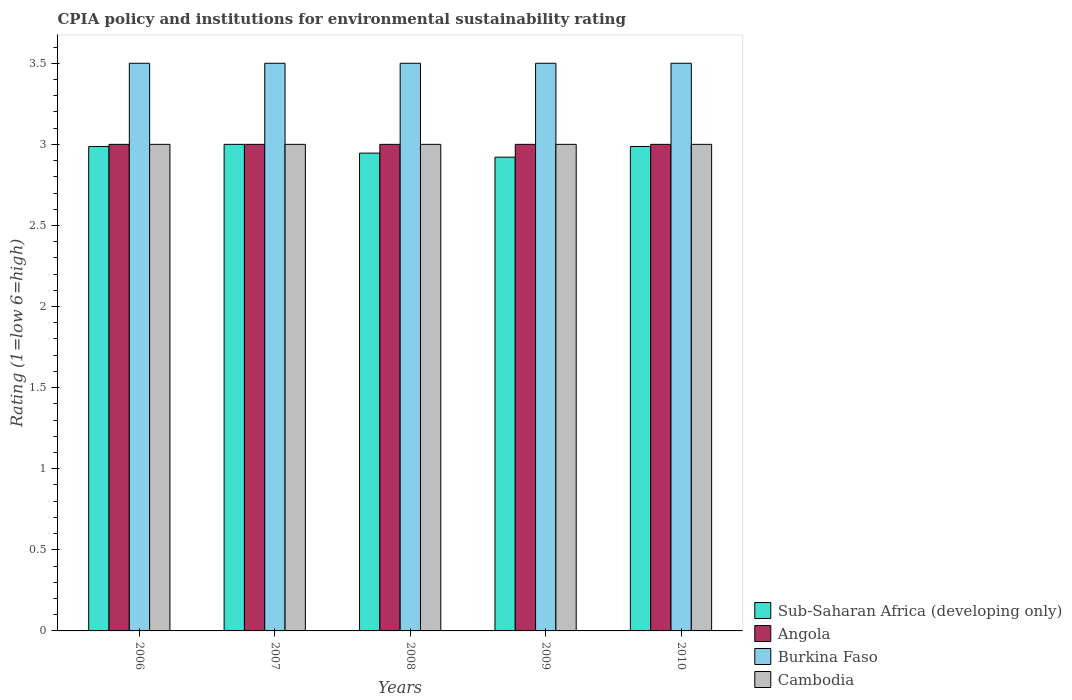How many different coloured bars are there?
Your response must be concise. 4. How many groups of bars are there?
Offer a very short reply. 5. Are the number of bars per tick equal to the number of legend labels?
Provide a succinct answer. Yes. How many bars are there on the 2nd tick from the left?
Offer a terse response. 4. In how many cases, is the number of bars for a given year not equal to the number of legend labels?
Offer a very short reply. 0. Across all years, what is the minimum CPIA rating in Sub-Saharan Africa (developing only)?
Make the answer very short. 2.92. What is the total CPIA rating in Angola in the graph?
Your answer should be compact. 15. Is the difference between the CPIA rating in Cambodia in 2006 and 2009 greater than the difference between the CPIA rating in Angola in 2006 and 2009?
Your response must be concise. No. What is the difference between the highest and the second highest CPIA rating in Cambodia?
Give a very brief answer. 0. Is it the case that in every year, the sum of the CPIA rating in Cambodia and CPIA rating in Sub-Saharan Africa (developing only) is greater than the sum of CPIA rating in Angola and CPIA rating in Burkina Faso?
Provide a succinct answer. No. What does the 4th bar from the left in 2006 represents?
Your response must be concise. Cambodia. What does the 4th bar from the right in 2008 represents?
Provide a short and direct response. Sub-Saharan Africa (developing only). What is the difference between two consecutive major ticks on the Y-axis?
Offer a very short reply. 0.5. Are the values on the major ticks of Y-axis written in scientific E-notation?
Make the answer very short. No. Does the graph contain any zero values?
Your response must be concise. No. Does the graph contain grids?
Offer a very short reply. No. How many legend labels are there?
Provide a short and direct response. 4. What is the title of the graph?
Give a very brief answer. CPIA policy and institutions for environmental sustainability rating. Does "Cuba" appear as one of the legend labels in the graph?
Your answer should be very brief. No. What is the label or title of the X-axis?
Make the answer very short. Years. What is the label or title of the Y-axis?
Provide a succinct answer. Rating (1=low 6=high). What is the Rating (1=low 6=high) in Sub-Saharan Africa (developing only) in 2006?
Offer a very short reply. 2.99. What is the Rating (1=low 6=high) of Angola in 2006?
Give a very brief answer. 3. What is the Rating (1=low 6=high) of Cambodia in 2007?
Give a very brief answer. 3. What is the Rating (1=low 6=high) in Sub-Saharan Africa (developing only) in 2008?
Ensure brevity in your answer.  2.95. What is the Rating (1=low 6=high) of Angola in 2008?
Your response must be concise. 3. What is the Rating (1=low 6=high) in Burkina Faso in 2008?
Your answer should be very brief. 3.5. What is the Rating (1=low 6=high) in Cambodia in 2008?
Provide a succinct answer. 3. What is the Rating (1=low 6=high) in Sub-Saharan Africa (developing only) in 2009?
Provide a short and direct response. 2.92. What is the Rating (1=low 6=high) in Angola in 2009?
Offer a terse response. 3. What is the Rating (1=low 6=high) of Burkina Faso in 2009?
Your answer should be compact. 3.5. What is the Rating (1=low 6=high) in Sub-Saharan Africa (developing only) in 2010?
Your answer should be compact. 2.99. What is the Rating (1=low 6=high) of Angola in 2010?
Ensure brevity in your answer.  3. What is the Rating (1=low 6=high) in Burkina Faso in 2010?
Offer a terse response. 3.5. Across all years, what is the maximum Rating (1=low 6=high) in Angola?
Your answer should be very brief. 3. Across all years, what is the maximum Rating (1=low 6=high) in Burkina Faso?
Ensure brevity in your answer.  3.5. Across all years, what is the maximum Rating (1=low 6=high) of Cambodia?
Keep it short and to the point. 3. Across all years, what is the minimum Rating (1=low 6=high) of Sub-Saharan Africa (developing only)?
Keep it short and to the point. 2.92. Across all years, what is the minimum Rating (1=low 6=high) of Burkina Faso?
Keep it short and to the point. 3.5. What is the total Rating (1=low 6=high) in Sub-Saharan Africa (developing only) in the graph?
Give a very brief answer. 14.84. What is the total Rating (1=low 6=high) in Angola in the graph?
Your response must be concise. 15. What is the difference between the Rating (1=low 6=high) of Sub-Saharan Africa (developing only) in 2006 and that in 2007?
Offer a very short reply. -0.01. What is the difference between the Rating (1=low 6=high) of Angola in 2006 and that in 2007?
Your response must be concise. 0. What is the difference between the Rating (1=low 6=high) in Burkina Faso in 2006 and that in 2007?
Offer a very short reply. 0. What is the difference between the Rating (1=low 6=high) in Sub-Saharan Africa (developing only) in 2006 and that in 2008?
Your response must be concise. 0.04. What is the difference between the Rating (1=low 6=high) of Angola in 2006 and that in 2008?
Provide a succinct answer. 0. What is the difference between the Rating (1=low 6=high) in Burkina Faso in 2006 and that in 2008?
Your answer should be very brief. 0. What is the difference between the Rating (1=low 6=high) in Cambodia in 2006 and that in 2008?
Offer a very short reply. 0. What is the difference between the Rating (1=low 6=high) in Sub-Saharan Africa (developing only) in 2006 and that in 2009?
Offer a terse response. 0.07. What is the difference between the Rating (1=low 6=high) in Burkina Faso in 2006 and that in 2009?
Provide a short and direct response. 0. What is the difference between the Rating (1=low 6=high) in Sub-Saharan Africa (developing only) in 2006 and that in 2010?
Provide a short and direct response. -0. What is the difference between the Rating (1=low 6=high) in Burkina Faso in 2006 and that in 2010?
Ensure brevity in your answer.  0. What is the difference between the Rating (1=low 6=high) of Sub-Saharan Africa (developing only) in 2007 and that in 2008?
Provide a succinct answer. 0.05. What is the difference between the Rating (1=low 6=high) in Burkina Faso in 2007 and that in 2008?
Offer a terse response. 0. What is the difference between the Rating (1=low 6=high) of Sub-Saharan Africa (developing only) in 2007 and that in 2009?
Your answer should be compact. 0.08. What is the difference between the Rating (1=low 6=high) in Burkina Faso in 2007 and that in 2009?
Your answer should be very brief. 0. What is the difference between the Rating (1=low 6=high) of Cambodia in 2007 and that in 2009?
Keep it short and to the point. 0. What is the difference between the Rating (1=low 6=high) of Sub-Saharan Africa (developing only) in 2007 and that in 2010?
Keep it short and to the point. 0.01. What is the difference between the Rating (1=low 6=high) of Cambodia in 2007 and that in 2010?
Your response must be concise. 0. What is the difference between the Rating (1=low 6=high) of Sub-Saharan Africa (developing only) in 2008 and that in 2009?
Make the answer very short. 0.02. What is the difference between the Rating (1=low 6=high) in Burkina Faso in 2008 and that in 2009?
Provide a succinct answer. 0. What is the difference between the Rating (1=low 6=high) of Cambodia in 2008 and that in 2009?
Offer a very short reply. 0. What is the difference between the Rating (1=low 6=high) in Sub-Saharan Africa (developing only) in 2008 and that in 2010?
Offer a very short reply. -0.04. What is the difference between the Rating (1=low 6=high) of Angola in 2008 and that in 2010?
Provide a succinct answer. 0. What is the difference between the Rating (1=low 6=high) of Burkina Faso in 2008 and that in 2010?
Ensure brevity in your answer.  0. What is the difference between the Rating (1=low 6=high) in Cambodia in 2008 and that in 2010?
Make the answer very short. 0. What is the difference between the Rating (1=low 6=high) in Sub-Saharan Africa (developing only) in 2009 and that in 2010?
Your answer should be very brief. -0.07. What is the difference between the Rating (1=low 6=high) of Angola in 2009 and that in 2010?
Provide a succinct answer. 0. What is the difference between the Rating (1=low 6=high) in Burkina Faso in 2009 and that in 2010?
Your answer should be compact. 0. What is the difference between the Rating (1=low 6=high) in Cambodia in 2009 and that in 2010?
Provide a succinct answer. 0. What is the difference between the Rating (1=low 6=high) of Sub-Saharan Africa (developing only) in 2006 and the Rating (1=low 6=high) of Angola in 2007?
Keep it short and to the point. -0.01. What is the difference between the Rating (1=low 6=high) in Sub-Saharan Africa (developing only) in 2006 and the Rating (1=low 6=high) in Burkina Faso in 2007?
Offer a very short reply. -0.51. What is the difference between the Rating (1=low 6=high) in Sub-Saharan Africa (developing only) in 2006 and the Rating (1=low 6=high) in Cambodia in 2007?
Offer a very short reply. -0.01. What is the difference between the Rating (1=low 6=high) in Angola in 2006 and the Rating (1=low 6=high) in Cambodia in 2007?
Offer a very short reply. 0. What is the difference between the Rating (1=low 6=high) of Sub-Saharan Africa (developing only) in 2006 and the Rating (1=low 6=high) of Angola in 2008?
Give a very brief answer. -0.01. What is the difference between the Rating (1=low 6=high) of Sub-Saharan Africa (developing only) in 2006 and the Rating (1=low 6=high) of Burkina Faso in 2008?
Give a very brief answer. -0.51. What is the difference between the Rating (1=low 6=high) of Sub-Saharan Africa (developing only) in 2006 and the Rating (1=low 6=high) of Cambodia in 2008?
Ensure brevity in your answer.  -0.01. What is the difference between the Rating (1=low 6=high) of Angola in 2006 and the Rating (1=low 6=high) of Burkina Faso in 2008?
Ensure brevity in your answer.  -0.5. What is the difference between the Rating (1=low 6=high) of Burkina Faso in 2006 and the Rating (1=low 6=high) of Cambodia in 2008?
Provide a succinct answer. 0.5. What is the difference between the Rating (1=low 6=high) in Sub-Saharan Africa (developing only) in 2006 and the Rating (1=low 6=high) in Angola in 2009?
Provide a succinct answer. -0.01. What is the difference between the Rating (1=low 6=high) of Sub-Saharan Africa (developing only) in 2006 and the Rating (1=low 6=high) of Burkina Faso in 2009?
Your answer should be compact. -0.51. What is the difference between the Rating (1=low 6=high) of Sub-Saharan Africa (developing only) in 2006 and the Rating (1=low 6=high) of Cambodia in 2009?
Your answer should be compact. -0.01. What is the difference between the Rating (1=low 6=high) of Angola in 2006 and the Rating (1=low 6=high) of Burkina Faso in 2009?
Provide a short and direct response. -0.5. What is the difference between the Rating (1=low 6=high) of Burkina Faso in 2006 and the Rating (1=low 6=high) of Cambodia in 2009?
Provide a short and direct response. 0.5. What is the difference between the Rating (1=low 6=high) of Sub-Saharan Africa (developing only) in 2006 and the Rating (1=low 6=high) of Angola in 2010?
Provide a succinct answer. -0.01. What is the difference between the Rating (1=low 6=high) in Sub-Saharan Africa (developing only) in 2006 and the Rating (1=low 6=high) in Burkina Faso in 2010?
Offer a very short reply. -0.51. What is the difference between the Rating (1=low 6=high) of Sub-Saharan Africa (developing only) in 2006 and the Rating (1=low 6=high) of Cambodia in 2010?
Provide a succinct answer. -0.01. What is the difference between the Rating (1=low 6=high) of Angola in 2006 and the Rating (1=low 6=high) of Burkina Faso in 2010?
Your answer should be very brief. -0.5. What is the difference between the Rating (1=low 6=high) in Angola in 2006 and the Rating (1=low 6=high) in Cambodia in 2010?
Your answer should be compact. 0. What is the difference between the Rating (1=low 6=high) in Burkina Faso in 2006 and the Rating (1=low 6=high) in Cambodia in 2010?
Make the answer very short. 0.5. What is the difference between the Rating (1=low 6=high) in Angola in 2007 and the Rating (1=low 6=high) in Cambodia in 2008?
Ensure brevity in your answer.  0. What is the difference between the Rating (1=low 6=high) in Angola in 2007 and the Rating (1=low 6=high) in Burkina Faso in 2009?
Offer a very short reply. -0.5. What is the difference between the Rating (1=low 6=high) in Burkina Faso in 2007 and the Rating (1=low 6=high) in Cambodia in 2009?
Ensure brevity in your answer.  0.5. What is the difference between the Rating (1=low 6=high) of Sub-Saharan Africa (developing only) in 2008 and the Rating (1=low 6=high) of Angola in 2009?
Your answer should be very brief. -0.05. What is the difference between the Rating (1=low 6=high) of Sub-Saharan Africa (developing only) in 2008 and the Rating (1=low 6=high) of Burkina Faso in 2009?
Your answer should be compact. -0.55. What is the difference between the Rating (1=low 6=high) of Sub-Saharan Africa (developing only) in 2008 and the Rating (1=low 6=high) of Cambodia in 2009?
Provide a short and direct response. -0.05. What is the difference between the Rating (1=low 6=high) in Angola in 2008 and the Rating (1=low 6=high) in Burkina Faso in 2009?
Offer a terse response. -0.5. What is the difference between the Rating (1=low 6=high) of Angola in 2008 and the Rating (1=low 6=high) of Cambodia in 2009?
Your answer should be very brief. 0. What is the difference between the Rating (1=low 6=high) of Sub-Saharan Africa (developing only) in 2008 and the Rating (1=low 6=high) of Angola in 2010?
Offer a very short reply. -0.05. What is the difference between the Rating (1=low 6=high) of Sub-Saharan Africa (developing only) in 2008 and the Rating (1=low 6=high) of Burkina Faso in 2010?
Give a very brief answer. -0.55. What is the difference between the Rating (1=low 6=high) of Sub-Saharan Africa (developing only) in 2008 and the Rating (1=low 6=high) of Cambodia in 2010?
Provide a short and direct response. -0.05. What is the difference between the Rating (1=low 6=high) in Angola in 2008 and the Rating (1=low 6=high) in Burkina Faso in 2010?
Your answer should be compact. -0.5. What is the difference between the Rating (1=low 6=high) in Sub-Saharan Africa (developing only) in 2009 and the Rating (1=low 6=high) in Angola in 2010?
Provide a short and direct response. -0.08. What is the difference between the Rating (1=low 6=high) in Sub-Saharan Africa (developing only) in 2009 and the Rating (1=low 6=high) in Burkina Faso in 2010?
Offer a very short reply. -0.58. What is the difference between the Rating (1=low 6=high) of Sub-Saharan Africa (developing only) in 2009 and the Rating (1=low 6=high) of Cambodia in 2010?
Your answer should be compact. -0.08. What is the difference between the Rating (1=low 6=high) in Angola in 2009 and the Rating (1=low 6=high) in Cambodia in 2010?
Provide a short and direct response. 0. What is the average Rating (1=low 6=high) in Sub-Saharan Africa (developing only) per year?
Provide a short and direct response. 2.97. What is the average Rating (1=low 6=high) of Angola per year?
Your response must be concise. 3. What is the average Rating (1=low 6=high) of Cambodia per year?
Make the answer very short. 3. In the year 2006, what is the difference between the Rating (1=low 6=high) in Sub-Saharan Africa (developing only) and Rating (1=low 6=high) in Angola?
Your answer should be compact. -0.01. In the year 2006, what is the difference between the Rating (1=low 6=high) of Sub-Saharan Africa (developing only) and Rating (1=low 6=high) of Burkina Faso?
Provide a short and direct response. -0.51. In the year 2006, what is the difference between the Rating (1=low 6=high) of Sub-Saharan Africa (developing only) and Rating (1=low 6=high) of Cambodia?
Provide a short and direct response. -0.01. In the year 2006, what is the difference between the Rating (1=low 6=high) in Angola and Rating (1=low 6=high) in Burkina Faso?
Make the answer very short. -0.5. In the year 2006, what is the difference between the Rating (1=low 6=high) in Angola and Rating (1=low 6=high) in Cambodia?
Offer a very short reply. 0. In the year 2007, what is the difference between the Rating (1=low 6=high) in Angola and Rating (1=low 6=high) in Burkina Faso?
Make the answer very short. -0.5. In the year 2007, what is the difference between the Rating (1=low 6=high) of Angola and Rating (1=low 6=high) of Cambodia?
Keep it short and to the point. 0. In the year 2008, what is the difference between the Rating (1=low 6=high) in Sub-Saharan Africa (developing only) and Rating (1=low 6=high) in Angola?
Your answer should be very brief. -0.05. In the year 2008, what is the difference between the Rating (1=low 6=high) of Sub-Saharan Africa (developing only) and Rating (1=low 6=high) of Burkina Faso?
Your answer should be very brief. -0.55. In the year 2008, what is the difference between the Rating (1=low 6=high) of Sub-Saharan Africa (developing only) and Rating (1=low 6=high) of Cambodia?
Provide a short and direct response. -0.05. In the year 2008, what is the difference between the Rating (1=low 6=high) in Angola and Rating (1=low 6=high) in Cambodia?
Make the answer very short. 0. In the year 2008, what is the difference between the Rating (1=low 6=high) in Burkina Faso and Rating (1=low 6=high) in Cambodia?
Provide a succinct answer. 0.5. In the year 2009, what is the difference between the Rating (1=low 6=high) of Sub-Saharan Africa (developing only) and Rating (1=low 6=high) of Angola?
Your answer should be very brief. -0.08. In the year 2009, what is the difference between the Rating (1=low 6=high) of Sub-Saharan Africa (developing only) and Rating (1=low 6=high) of Burkina Faso?
Your response must be concise. -0.58. In the year 2009, what is the difference between the Rating (1=low 6=high) of Sub-Saharan Africa (developing only) and Rating (1=low 6=high) of Cambodia?
Offer a terse response. -0.08. In the year 2009, what is the difference between the Rating (1=low 6=high) in Angola and Rating (1=low 6=high) in Burkina Faso?
Offer a terse response. -0.5. In the year 2010, what is the difference between the Rating (1=low 6=high) of Sub-Saharan Africa (developing only) and Rating (1=low 6=high) of Angola?
Your answer should be very brief. -0.01. In the year 2010, what is the difference between the Rating (1=low 6=high) of Sub-Saharan Africa (developing only) and Rating (1=low 6=high) of Burkina Faso?
Offer a terse response. -0.51. In the year 2010, what is the difference between the Rating (1=low 6=high) of Sub-Saharan Africa (developing only) and Rating (1=low 6=high) of Cambodia?
Provide a succinct answer. -0.01. In the year 2010, what is the difference between the Rating (1=low 6=high) in Angola and Rating (1=low 6=high) in Burkina Faso?
Make the answer very short. -0.5. In the year 2010, what is the difference between the Rating (1=low 6=high) of Burkina Faso and Rating (1=low 6=high) of Cambodia?
Make the answer very short. 0.5. What is the ratio of the Rating (1=low 6=high) in Sub-Saharan Africa (developing only) in 2006 to that in 2007?
Make the answer very short. 1. What is the ratio of the Rating (1=low 6=high) of Cambodia in 2006 to that in 2007?
Your answer should be very brief. 1. What is the ratio of the Rating (1=low 6=high) in Sub-Saharan Africa (developing only) in 2006 to that in 2008?
Keep it short and to the point. 1.01. What is the ratio of the Rating (1=low 6=high) in Angola in 2006 to that in 2008?
Provide a succinct answer. 1. What is the ratio of the Rating (1=low 6=high) in Cambodia in 2006 to that in 2008?
Your answer should be very brief. 1. What is the ratio of the Rating (1=low 6=high) of Sub-Saharan Africa (developing only) in 2006 to that in 2009?
Offer a very short reply. 1.02. What is the ratio of the Rating (1=low 6=high) of Sub-Saharan Africa (developing only) in 2006 to that in 2010?
Ensure brevity in your answer.  1. What is the ratio of the Rating (1=low 6=high) of Angola in 2006 to that in 2010?
Your response must be concise. 1. What is the ratio of the Rating (1=low 6=high) in Cambodia in 2006 to that in 2010?
Your response must be concise. 1. What is the ratio of the Rating (1=low 6=high) of Sub-Saharan Africa (developing only) in 2007 to that in 2008?
Offer a very short reply. 1.02. What is the ratio of the Rating (1=low 6=high) of Angola in 2007 to that in 2008?
Give a very brief answer. 1. What is the ratio of the Rating (1=low 6=high) in Burkina Faso in 2007 to that in 2008?
Your response must be concise. 1. What is the ratio of the Rating (1=low 6=high) in Cambodia in 2007 to that in 2008?
Your answer should be very brief. 1. What is the ratio of the Rating (1=low 6=high) of Sub-Saharan Africa (developing only) in 2007 to that in 2009?
Provide a short and direct response. 1.03. What is the ratio of the Rating (1=low 6=high) of Angola in 2007 to that in 2009?
Provide a succinct answer. 1. What is the ratio of the Rating (1=low 6=high) of Burkina Faso in 2007 to that in 2009?
Provide a succinct answer. 1. What is the ratio of the Rating (1=low 6=high) of Cambodia in 2007 to that in 2009?
Offer a terse response. 1. What is the ratio of the Rating (1=low 6=high) of Sub-Saharan Africa (developing only) in 2007 to that in 2010?
Your answer should be compact. 1. What is the ratio of the Rating (1=low 6=high) in Burkina Faso in 2007 to that in 2010?
Ensure brevity in your answer.  1. What is the ratio of the Rating (1=low 6=high) in Sub-Saharan Africa (developing only) in 2008 to that in 2009?
Your answer should be compact. 1.01. What is the ratio of the Rating (1=low 6=high) in Angola in 2008 to that in 2009?
Keep it short and to the point. 1. What is the ratio of the Rating (1=low 6=high) in Burkina Faso in 2008 to that in 2009?
Ensure brevity in your answer.  1. What is the ratio of the Rating (1=low 6=high) of Sub-Saharan Africa (developing only) in 2008 to that in 2010?
Your answer should be compact. 0.99. What is the ratio of the Rating (1=low 6=high) of Angola in 2008 to that in 2010?
Offer a very short reply. 1. What is the ratio of the Rating (1=low 6=high) of Burkina Faso in 2009 to that in 2010?
Your answer should be very brief. 1. What is the ratio of the Rating (1=low 6=high) in Cambodia in 2009 to that in 2010?
Give a very brief answer. 1. What is the difference between the highest and the second highest Rating (1=low 6=high) of Sub-Saharan Africa (developing only)?
Offer a terse response. 0.01. What is the difference between the highest and the second highest Rating (1=low 6=high) in Burkina Faso?
Offer a very short reply. 0. What is the difference between the highest and the second highest Rating (1=low 6=high) in Cambodia?
Make the answer very short. 0. What is the difference between the highest and the lowest Rating (1=low 6=high) of Sub-Saharan Africa (developing only)?
Offer a very short reply. 0.08. What is the difference between the highest and the lowest Rating (1=low 6=high) of Burkina Faso?
Offer a terse response. 0. 